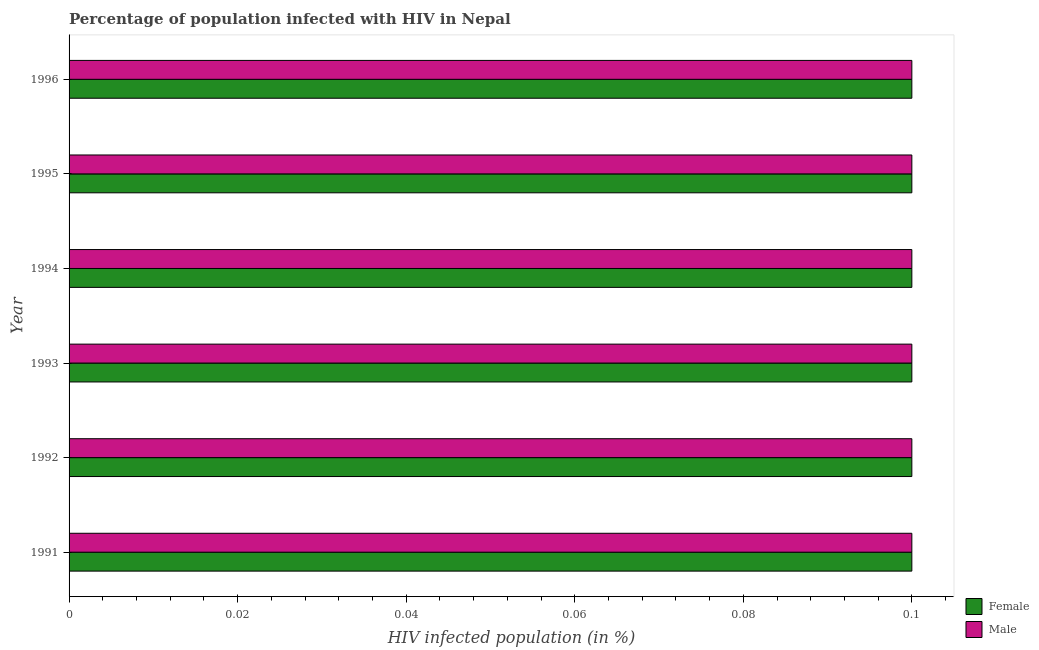How many different coloured bars are there?
Ensure brevity in your answer.  2. Are the number of bars per tick equal to the number of legend labels?
Your response must be concise. Yes. What is the label of the 4th group of bars from the top?
Ensure brevity in your answer.  1993. In how many cases, is the number of bars for a given year not equal to the number of legend labels?
Your response must be concise. 0. What is the percentage of females who are infected with hiv in 1993?
Your response must be concise. 0.1. Across all years, what is the minimum percentage of females who are infected with hiv?
Offer a very short reply. 0.1. What is the average percentage of males who are infected with hiv per year?
Your response must be concise. 0.1. In the year 1993, what is the difference between the percentage of males who are infected with hiv and percentage of females who are infected with hiv?
Provide a short and direct response. 0. In how many years, is the percentage of females who are infected with hiv greater than 0.044 %?
Offer a very short reply. 6. What is the ratio of the percentage of females who are infected with hiv in 1995 to that in 1996?
Your response must be concise. 1. Is the percentage of females who are infected with hiv in 1994 less than that in 1996?
Your answer should be very brief. No. Is the difference between the percentage of males who are infected with hiv in 1992 and 1993 greater than the difference between the percentage of females who are infected with hiv in 1992 and 1993?
Offer a terse response. No. What is the difference between the highest and the lowest percentage of males who are infected with hiv?
Keep it short and to the point. 0. In how many years, is the percentage of males who are infected with hiv greater than the average percentage of males who are infected with hiv taken over all years?
Your response must be concise. 6. What does the 2nd bar from the top in 1992 represents?
Offer a terse response. Female. What does the 1st bar from the bottom in 1996 represents?
Offer a terse response. Female. How many years are there in the graph?
Provide a short and direct response. 6. What is the difference between two consecutive major ticks on the X-axis?
Make the answer very short. 0.02. Does the graph contain any zero values?
Keep it short and to the point. No. How are the legend labels stacked?
Give a very brief answer. Vertical. What is the title of the graph?
Provide a succinct answer. Percentage of population infected with HIV in Nepal. Does "Public funds" appear as one of the legend labels in the graph?
Give a very brief answer. No. What is the label or title of the X-axis?
Give a very brief answer. HIV infected population (in %). What is the label or title of the Y-axis?
Your answer should be very brief. Year. What is the HIV infected population (in %) in Female in 1991?
Provide a short and direct response. 0.1. What is the HIV infected population (in %) of Male in 1991?
Your response must be concise. 0.1. What is the HIV infected population (in %) of Female in 1993?
Make the answer very short. 0.1. What is the HIV infected population (in %) of Male in 1993?
Keep it short and to the point. 0.1. What is the HIV infected population (in %) in Female in 1994?
Keep it short and to the point. 0.1. What is the HIV infected population (in %) in Female in 1995?
Your answer should be compact. 0.1. What is the HIV infected population (in %) in Male in 1995?
Your answer should be compact. 0.1. What is the HIV infected population (in %) in Female in 1996?
Offer a very short reply. 0.1. What is the HIV infected population (in %) of Male in 1996?
Provide a succinct answer. 0.1. Across all years, what is the maximum HIV infected population (in %) in Female?
Your answer should be compact. 0.1. Across all years, what is the minimum HIV infected population (in %) of Female?
Give a very brief answer. 0.1. Across all years, what is the minimum HIV infected population (in %) in Male?
Give a very brief answer. 0.1. What is the total HIV infected population (in %) in Female in the graph?
Your response must be concise. 0.6. What is the difference between the HIV infected population (in %) in Female in 1991 and that in 1992?
Provide a short and direct response. 0. What is the difference between the HIV infected population (in %) in Male in 1991 and that in 1992?
Your response must be concise. 0. What is the difference between the HIV infected population (in %) of Female in 1991 and that in 1993?
Your answer should be compact. 0. What is the difference between the HIV infected population (in %) of Male in 1991 and that in 1993?
Your answer should be very brief. 0. What is the difference between the HIV infected population (in %) in Female in 1991 and that in 1994?
Give a very brief answer. 0. What is the difference between the HIV infected population (in %) in Female in 1991 and that in 1995?
Provide a short and direct response. 0. What is the difference between the HIV infected population (in %) of Female in 1991 and that in 1996?
Provide a short and direct response. 0. What is the difference between the HIV infected population (in %) in Female in 1992 and that in 1993?
Offer a very short reply. 0. What is the difference between the HIV infected population (in %) of Male in 1992 and that in 1993?
Offer a terse response. 0. What is the difference between the HIV infected population (in %) in Male in 1992 and that in 1995?
Give a very brief answer. 0. What is the difference between the HIV infected population (in %) of Female in 1993 and that in 1996?
Your answer should be very brief. 0. What is the difference between the HIV infected population (in %) of Female in 1994 and that in 1995?
Offer a very short reply. 0. What is the difference between the HIV infected population (in %) in Female in 1994 and that in 1996?
Provide a short and direct response. 0. What is the difference between the HIV infected population (in %) of Female in 1995 and that in 1996?
Give a very brief answer. 0. What is the difference between the HIV infected population (in %) in Female in 1991 and the HIV infected population (in %) in Male in 1995?
Offer a terse response. 0. What is the difference between the HIV infected population (in %) in Female in 1991 and the HIV infected population (in %) in Male in 1996?
Offer a very short reply. 0. What is the difference between the HIV infected population (in %) of Female in 1992 and the HIV infected population (in %) of Male in 1993?
Your answer should be compact. 0. What is the difference between the HIV infected population (in %) of Female in 1992 and the HIV infected population (in %) of Male in 1994?
Provide a short and direct response. 0. What is the difference between the HIV infected population (in %) of Female in 1992 and the HIV infected population (in %) of Male in 1995?
Offer a very short reply. 0. What is the difference between the HIV infected population (in %) of Female in 1993 and the HIV infected population (in %) of Male in 1994?
Give a very brief answer. 0. What is the average HIV infected population (in %) of Female per year?
Your answer should be compact. 0.1. In the year 1993, what is the difference between the HIV infected population (in %) of Female and HIV infected population (in %) of Male?
Your answer should be compact. 0. In the year 1994, what is the difference between the HIV infected population (in %) in Female and HIV infected population (in %) in Male?
Offer a terse response. 0. In the year 1996, what is the difference between the HIV infected population (in %) of Female and HIV infected population (in %) of Male?
Ensure brevity in your answer.  0. What is the ratio of the HIV infected population (in %) of Male in 1991 to that in 1993?
Ensure brevity in your answer.  1. What is the ratio of the HIV infected population (in %) in Female in 1991 to that in 1995?
Your answer should be very brief. 1. What is the ratio of the HIV infected population (in %) of Male in 1991 to that in 1996?
Provide a short and direct response. 1. What is the ratio of the HIV infected population (in %) in Male in 1992 to that in 1993?
Your response must be concise. 1. What is the ratio of the HIV infected population (in %) of Male in 1992 to that in 1994?
Your answer should be very brief. 1. What is the ratio of the HIV infected population (in %) of Female in 1992 to that in 1995?
Give a very brief answer. 1. What is the ratio of the HIV infected population (in %) of Female in 1992 to that in 1996?
Make the answer very short. 1. What is the ratio of the HIV infected population (in %) of Female in 1993 to that in 1995?
Ensure brevity in your answer.  1. What is the ratio of the HIV infected population (in %) of Male in 1993 to that in 1995?
Ensure brevity in your answer.  1. What is the ratio of the HIV infected population (in %) of Female in 1994 to that in 1995?
Give a very brief answer. 1. What is the ratio of the HIV infected population (in %) in Female in 1994 to that in 1996?
Ensure brevity in your answer.  1. What is the ratio of the HIV infected population (in %) in Female in 1995 to that in 1996?
Your response must be concise. 1. What is the ratio of the HIV infected population (in %) in Male in 1995 to that in 1996?
Make the answer very short. 1. What is the difference between the highest and the lowest HIV infected population (in %) of Male?
Provide a short and direct response. 0. 